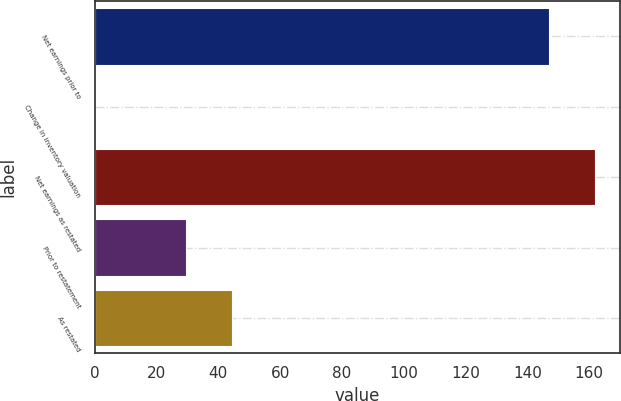Convert chart to OTSL. <chart><loc_0><loc_0><loc_500><loc_500><bar_chart><fcel>Net earnings prior to<fcel>Change in inventory valuation<fcel>Net earnings as restated<fcel>Prior to restatement<fcel>As restated<nl><fcel>147<fcel>0.02<fcel>161.8<fcel>29.62<fcel>44.42<nl></chart> 